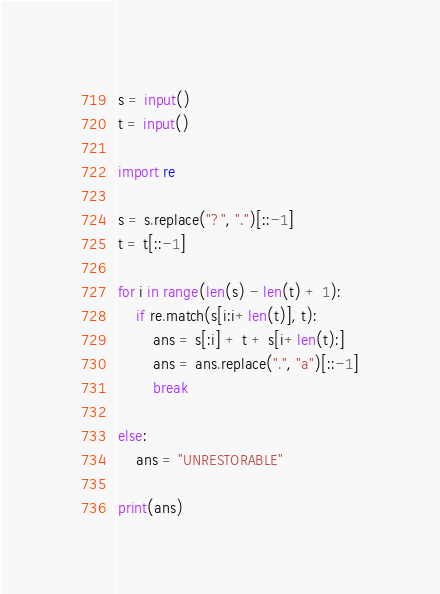Convert code to text. <code><loc_0><loc_0><loc_500><loc_500><_Python_>s = input()
t = input()

import re

s = s.replace("?", ".")[::-1]
t = t[::-1]

for i in range(len(s) - len(t) + 1):
    if re.match(s[i:i+len(t)], t):
        ans = s[:i] + t + s[i+len(t):]
        ans = ans.replace(".", "a")[::-1]
        break

else:
    ans = "UNRESTORABLE"

print(ans)
</code> 